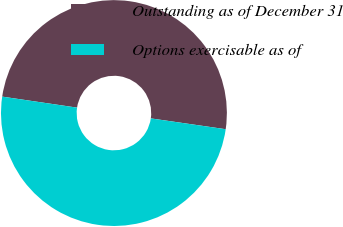Convert chart. <chart><loc_0><loc_0><loc_500><loc_500><pie_chart><fcel>Outstanding as of December 31<fcel>Options exercisable as of<nl><fcel>49.96%<fcel>50.04%<nl></chart> 